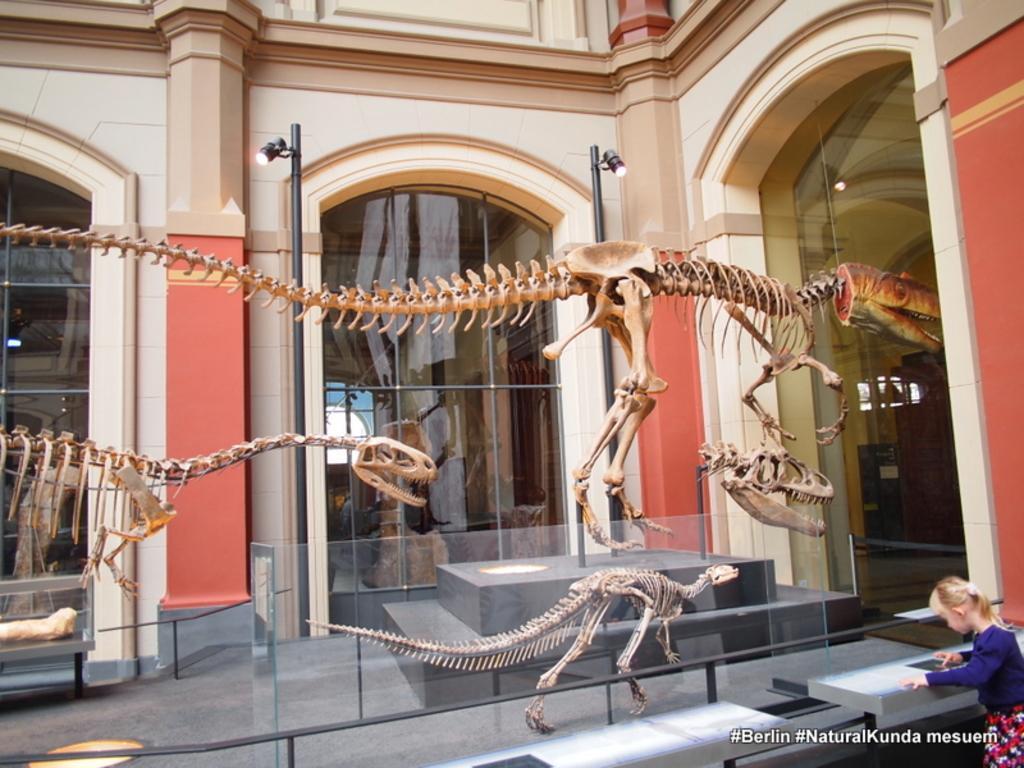Could you give a brief overview of what you see in this image? In this image we can see skeletons of dinosaurs which are behind the glass door and at the background of the image there is building and at the foreground of the image there is a kid wearing blue color dress standing. 